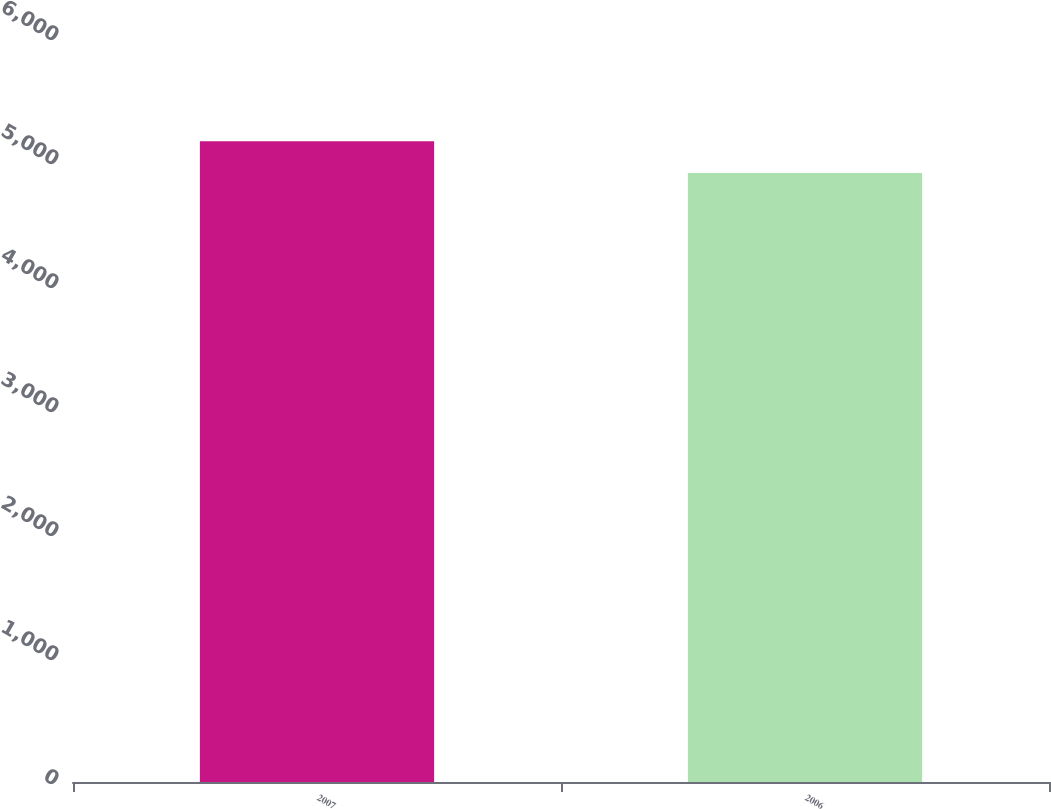Convert chart to OTSL. <chart><loc_0><loc_0><loc_500><loc_500><bar_chart><fcel>2007<fcel>2006<nl><fcel>5168<fcel>4912<nl></chart> 